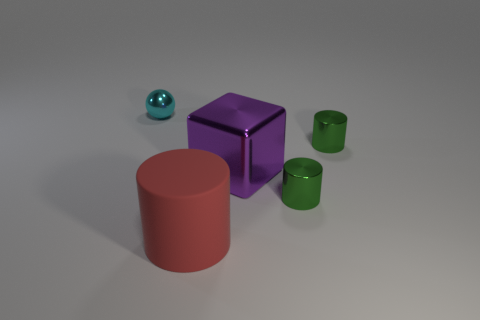Is there any other thing that has the same shape as the small cyan metallic thing?
Give a very brief answer. No. There is a object right of the tiny cylinder that is in front of the large thing that is behind the big red matte cylinder; what is its color?
Offer a terse response. Green. The large cylinder has what color?
Offer a terse response. Red. What shape is the tiny shiny thing that is in front of the big thing behind the cylinder to the left of the purple thing?
Your answer should be compact. Cylinder. What number of other things are the same color as the small shiny ball?
Keep it short and to the point. 0. Are there more matte cylinders to the right of the large cylinder than purple cubes that are behind the metallic ball?
Keep it short and to the point. No. There is a red thing; are there any small green things behind it?
Provide a succinct answer. Yes. There is a object that is to the left of the big purple metal cube and to the right of the tiny cyan thing; what is its material?
Your response must be concise. Rubber. Is there a tiny green shiny cylinder behind the big object that is on the right side of the red thing?
Provide a short and direct response. Yes. The cyan thing is what size?
Make the answer very short. Small. 